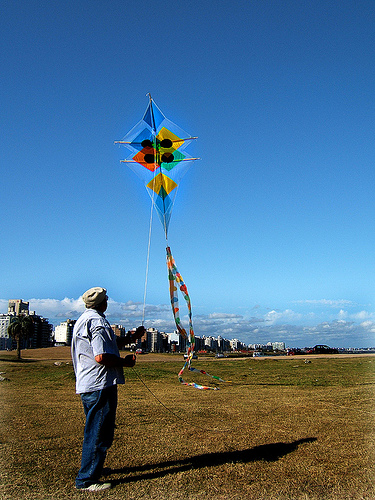How many people are pictured? There is 1 person visible in the image. He appears to be enjoying the outdoors, flying a colorful kite on a clear, sunny day. 